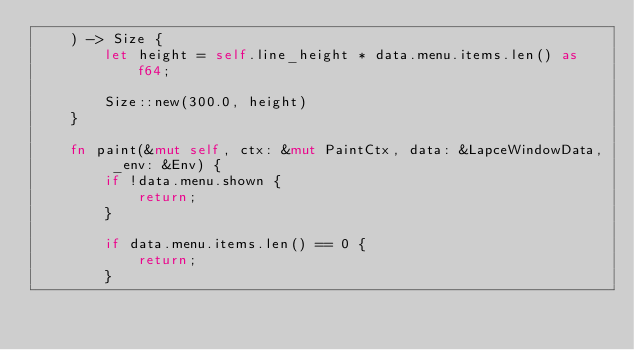<code> <loc_0><loc_0><loc_500><loc_500><_Rust_>    ) -> Size {
        let height = self.line_height * data.menu.items.len() as f64;

        Size::new(300.0, height)
    }

    fn paint(&mut self, ctx: &mut PaintCtx, data: &LapceWindowData, _env: &Env) {
        if !data.menu.shown {
            return;
        }

        if data.menu.items.len() == 0 {
            return;
        }
</code> 